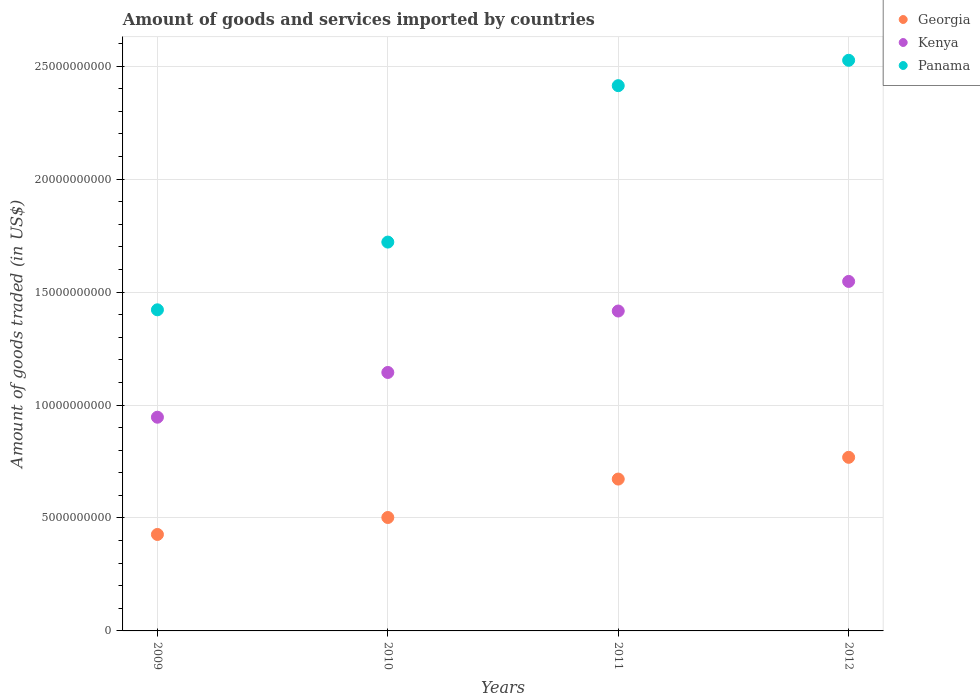How many different coloured dotlines are there?
Your response must be concise. 3. What is the total amount of goods and services imported in Georgia in 2010?
Your answer should be very brief. 5.02e+09. Across all years, what is the maximum total amount of goods and services imported in Kenya?
Offer a terse response. 1.55e+1. Across all years, what is the minimum total amount of goods and services imported in Georgia?
Offer a very short reply. 4.27e+09. In which year was the total amount of goods and services imported in Kenya minimum?
Give a very brief answer. 2009. What is the total total amount of goods and services imported in Kenya in the graph?
Your response must be concise. 5.05e+1. What is the difference between the total amount of goods and services imported in Kenya in 2011 and that in 2012?
Your response must be concise. -1.31e+09. What is the difference between the total amount of goods and services imported in Panama in 2011 and the total amount of goods and services imported in Kenya in 2009?
Your answer should be compact. 1.47e+1. What is the average total amount of goods and services imported in Georgia per year?
Ensure brevity in your answer.  5.92e+09. In the year 2012, what is the difference between the total amount of goods and services imported in Kenya and total amount of goods and services imported in Panama?
Your response must be concise. -9.79e+09. What is the ratio of the total amount of goods and services imported in Georgia in 2010 to that in 2012?
Ensure brevity in your answer.  0.65. Is the total amount of goods and services imported in Kenya in 2010 less than that in 2011?
Provide a short and direct response. Yes. What is the difference between the highest and the second highest total amount of goods and services imported in Kenya?
Give a very brief answer. 1.31e+09. What is the difference between the highest and the lowest total amount of goods and services imported in Georgia?
Your response must be concise. 3.41e+09. Is the sum of the total amount of goods and services imported in Panama in 2009 and 2012 greater than the maximum total amount of goods and services imported in Georgia across all years?
Your answer should be compact. Yes. Does the total amount of goods and services imported in Kenya monotonically increase over the years?
Provide a short and direct response. Yes. Is the total amount of goods and services imported in Panama strictly greater than the total amount of goods and services imported in Georgia over the years?
Provide a succinct answer. Yes. Is the total amount of goods and services imported in Panama strictly less than the total amount of goods and services imported in Kenya over the years?
Ensure brevity in your answer.  No. How many dotlines are there?
Offer a terse response. 3. Are the values on the major ticks of Y-axis written in scientific E-notation?
Make the answer very short. No. What is the title of the graph?
Your answer should be compact. Amount of goods and services imported by countries. What is the label or title of the Y-axis?
Your answer should be compact. Amount of goods traded (in US$). What is the Amount of goods traded (in US$) in Georgia in 2009?
Keep it short and to the point. 4.27e+09. What is the Amount of goods traded (in US$) in Kenya in 2009?
Give a very brief answer. 9.46e+09. What is the Amount of goods traded (in US$) in Panama in 2009?
Your answer should be compact. 1.42e+1. What is the Amount of goods traded (in US$) in Georgia in 2010?
Your answer should be compact. 5.02e+09. What is the Amount of goods traded (in US$) of Kenya in 2010?
Offer a terse response. 1.14e+1. What is the Amount of goods traded (in US$) in Panama in 2010?
Keep it short and to the point. 1.72e+1. What is the Amount of goods traded (in US$) of Georgia in 2011?
Ensure brevity in your answer.  6.72e+09. What is the Amount of goods traded (in US$) in Kenya in 2011?
Keep it short and to the point. 1.42e+1. What is the Amount of goods traded (in US$) of Panama in 2011?
Your answer should be very brief. 2.41e+1. What is the Amount of goods traded (in US$) of Georgia in 2012?
Your answer should be compact. 7.69e+09. What is the Amount of goods traded (in US$) of Kenya in 2012?
Keep it short and to the point. 1.55e+1. What is the Amount of goods traded (in US$) of Panama in 2012?
Your answer should be very brief. 2.53e+1. Across all years, what is the maximum Amount of goods traded (in US$) of Georgia?
Keep it short and to the point. 7.69e+09. Across all years, what is the maximum Amount of goods traded (in US$) in Kenya?
Your response must be concise. 1.55e+1. Across all years, what is the maximum Amount of goods traded (in US$) in Panama?
Your response must be concise. 2.53e+1. Across all years, what is the minimum Amount of goods traded (in US$) in Georgia?
Provide a succinct answer. 4.27e+09. Across all years, what is the minimum Amount of goods traded (in US$) of Kenya?
Your answer should be compact. 9.46e+09. Across all years, what is the minimum Amount of goods traded (in US$) in Panama?
Your answer should be compact. 1.42e+1. What is the total Amount of goods traded (in US$) in Georgia in the graph?
Ensure brevity in your answer.  2.37e+1. What is the total Amount of goods traded (in US$) in Kenya in the graph?
Ensure brevity in your answer.  5.05e+1. What is the total Amount of goods traded (in US$) of Panama in the graph?
Provide a succinct answer. 8.08e+1. What is the difference between the Amount of goods traded (in US$) in Georgia in 2009 and that in 2010?
Offer a very short reply. -7.51e+08. What is the difference between the Amount of goods traded (in US$) in Kenya in 2009 and that in 2010?
Your answer should be compact. -1.98e+09. What is the difference between the Amount of goods traded (in US$) in Panama in 2009 and that in 2010?
Offer a very short reply. -3.00e+09. What is the difference between the Amount of goods traded (in US$) of Georgia in 2009 and that in 2011?
Ensure brevity in your answer.  -2.45e+09. What is the difference between the Amount of goods traded (in US$) in Kenya in 2009 and that in 2011?
Offer a terse response. -4.70e+09. What is the difference between the Amount of goods traded (in US$) of Panama in 2009 and that in 2011?
Ensure brevity in your answer.  -9.92e+09. What is the difference between the Amount of goods traded (in US$) of Georgia in 2009 and that in 2012?
Keep it short and to the point. -3.41e+09. What is the difference between the Amount of goods traded (in US$) of Kenya in 2009 and that in 2012?
Offer a very short reply. -6.01e+09. What is the difference between the Amount of goods traded (in US$) in Panama in 2009 and that in 2012?
Keep it short and to the point. -1.10e+1. What is the difference between the Amount of goods traded (in US$) of Georgia in 2010 and that in 2011?
Your answer should be very brief. -1.70e+09. What is the difference between the Amount of goods traded (in US$) of Kenya in 2010 and that in 2011?
Offer a very short reply. -2.72e+09. What is the difference between the Amount of goods traded (in US$) of Panama in 2010 and that in 2011?
Your answer should be very brief. -6.92e+09. What is the difference between the Amount of goods traded (in US$) of Georgia in 2010 and that in 2012?
Keep it short and to the point. -2.66e+09. What is the difference between the Amount of goods traded (in US$) in Kenya in 2010 and that in 2012?
Provide a short and direct response. -4.03e+09. What is the difference between the Amount of goods traded (in US$) of Panama in 2010 and that in 2012?
Your answer should be compact. -8.05e+09. What is the difference between the Amount of goods traded (in US$) in Georgia in 2011 and that in 2012?
Your answer should be very brief. -9.63e+08. What is the difference between the Amount of goods traded (in US$) of Kenya in 2011 and that in 2012?
Your answer should be very brief. -1.31e+09. What is the difference between the Amount of goods traded (in US$) in Panama in 2011 and that in 2012?
Ensure brevity in your answer.  -1.12e+09. What is the difference between the Amount of goods traded (in US$) of Georgia in 2009 and the Amount of goods traded (in US$) of Kenya in 2010?
Your answer should be compact. -7.17e+09. What is the difference between the Amount of goods traded (in US$) in Georgia in 2009 and the Amount of goods traded (in US$) in Panama in 2010?
Offer a terse response. -1.29e+1. What is the difference between the Amount of goods traded (in US$) of Kenya in 2009 and the Amount of goods traded (in US$) of Panama in 2010?
Make the answer very short. -7.75e+09. What is the difference between the Amount of goods traded (in US$) of Georgia in 2009 and the Amount of goods traded (in US$) of Kenya in 2011?
Make the answer very short. -9.89e+09. What is the difference between the Amount of goods traded (in US$) of Georgia in 2009 and the Amount of goods traded (in US$) of Panama in 2011?
Ensure brevity in your answer.  -1.99e+1. What is the difference between the Amount of goods traded (in US$) in Kenya in 2009 and the Amount of goods traded (in US$) in Panama in 2011?
Provide a succinct answer. -1.47e+1. What is the difference between the Amount of goods traded (in US$) of Georgia in 2009 and the Amount of goods traded (in US$) of Kenya in 2012?
Ensure brevity in your answer.  -1.12e+1. What is the difference between the Amount of goods traded (in US$) in Georgia in 2009 and the Amount of goods traded (in US$) in Panama in 2012?
Offer a terse response. -2.10e+1. What is the difference between the Amount of goods traded (in US$) of Kenya in 2009 and the Amount of goods traded (in US$) of Panama in 2012?
Offer a very short reply. -1.58e+1. What is the difference between the Amount of goods traded (in US$) in Georgia in 2010 and the Amount of goods traded (in US$) in Kenya in 2011?
Your response must be concise. -9.14e+09. What is the difference between the Amount of goods traded (in US$) in Georgia in 2010 and the Amount of goods traded (in US$) in Panama in 2011?
Make the answer very short. -1.91e+1. What is the difference between the Amount of goods traded (in US$) in Kenya in 2010 and the Amount of goods traded (in US$) in Panama in 2011?
Your answer should be compact. -1.27e+1. What is the difference between the Amount of goods traded (in US$) of Georgia in 2010 and the Amount of goods traded (in US$) of Kenya in 2012?
Make the answer very short. -1.05e+1. What is the difference between the Amount of goods traded (in US$) of Georgia in 2010 and the Amount of goods traded (in US$) of Panama in 2012?
Ensure brevity in your answer.  -2.02e+1. What is the difference between the Amount of goods traded (in US$) of Kenya in 2010 and the Amount of goods traded (in US$) of Panama in 2012?
Offer a very short reply. -1.38e+1. What is the difference between the Amount of goods traded (in US$) of Georgia in 2011 and the Amount of goods traded (in US$) of Kenya in 2012?
Give a very brief answer. -8.75e+09. What is the difference between the Amount of goods traded (in US$) of Georgia in 2011 and the Amount of goods traded (in US$) of Panama in 2012?
Offer a terse response. -1.85e+1. What is the difference between the Amount of goods traded (in US$) in Kenya in 2011 and the Amount of goods traded (in US$) in Panama in 2012?
Your answer should be very brief. -1.11e+1. What is the average Amount of goods traded (in US$) of Georgia per year?
Your answer should be very brief. 5.92e+09. What is the average Amount of goods traded (in US$) of Kenya per year?
Ensure brevity in your answer.  1.26e+1. What is the average Amount of goods traded (in US$) in Panama per year?
Your answer should be very brief. 2.02e+1. In the year 2009, what is the difference between the Amount of goods traded (in US$) in Georgia and Amount of goods traded (in US$) in Kenya?
Ensure brevity in your answer.  -5.19e+09. In the year 2009, what is the difference between the Amount of goods traded (in US$) of Georgia and Amount of goods traded (in US$) of Panama?
Give a very brief answer. -9.95e+09. In the year 2009, what is the difference between the Amount of goods traded (in US$) in Kenya and Amount of goods traded (in US$) in Panama?
Your response must be concise. -4.75e+09. In the year 2010, what is the difference between the Amount of goods traded (in US$) of Georgia and Amount of goods traded (in US$) of Kenya?
Your answer should be compact. -6.42e+09. In the year 2010, what is the difference between the Amount of goods traded (in US$) of Georgia and Amount of goods traded (in US$) of Panama?
Your answer should be very brief. -1.22e+1. In the year 2010, what is the difference between the Amount of goods traded (in US$) in Kenya and Amount of goods traded (in US$) in Panama?
Your response must be concise. -5.77e+09. In the year 2011, what is the difference between the Amount of goods traded (in US$) of Georgia and Amount of goods traded (in US$) of Kenya?
Ensure brevity in your answer.  -7.44e+09. In the year 2011, what is the difference between the Amount of goods traded (in US$) of Georgia and Amount of goods traded (in US$) of Panama?
Provide a succinct answer. -1.74e+1. In the year 2011, what is the difference between the Amount of goods traded (in US$) in Kenya and Amount of goods traded (in US$) in Panama?
Offer a terse response. -9.98e+09. In the year 2012, what is the difference between the Amount of goods traded (in US$) of Georgia and Amount of goods traded (in US$) of Kenya?
Offer a very short reply. -7.79e+09. In the year 2012, what is the difference between the Amount of goods traded (in US$) in Georgia and Amount of goods traded (in US$) in Panama?
Offer a terse response. -1.76e+1. In the year 2012, what is the difference between the Amount of goods traded (in US$) in Kenya and Amount of goods traded (in US$) in Panama?
Your answer should be compact. -9.79e+09. What is the ratio of the Amount of goods traded (in US$) of Georgia in 2009 to that in 2010?
Your answer should be very brief. 0.85. What is the ratio of the Amount of goods traded (in US$) of Kenya in 2009 to that in 2010?
Offer a terse response. 0.83. What is the ratio of the Amount of goods traded (in US$) in Panama in 2009 to that in 2010?
Provide a short and direct response. 0.83. What is the ratio of the Amount of goods traded (in US$) in Georgia in 2009 to that in 2011?
Your answer should be compact. 0.64. What is the ratio of the Amount of goods traded (in US$) of Kenya in 2009 to that in 2011?
Provide a short and direct response. 0.67. What is the ratio of the Amount of goods traded (in US$) of Panama in 2009 to that in 2011?
Your response must be concise. 0.59. What is the ratio of the Amount of goods traded (in US$) in Georgia in 2009 to that in 2012?
Your answer should be very brief. 0.56. What is the ratio of the Amount of goods traded (in US$) in Kenya in 2009 to that in 2012?
Offer a terse response. 0.61. What is the ratio of the Amount of goods traded (in US$) in Panama in 2009 to that in 2012?
Ensure brevity in your answer.  0.56. What is the ratio of the Amount of goods traded (in US$) of Georgia in 2010 to that in 2011?
Make the answer very short. 0.75. What is the ratio of the Amount of goods traded (in US$) of Kenya in 2010 to that in 2011?
Provide a succinct answer. 0.81. What is the ratio of the Amount of goods traded (in US$) in Panama in 2010 to that in 2011?
Ensure brevity in your answer.  0.71. What is the ratio of the Amount of goods traded (in US$) in Georgia in 2010 to that in 2012?
Offer a terse response. 0.65. What is the ratio of the Amount of goods traded (in US$) in Kenya in 2010 to that in 2012?
Your response must be concise. 0.74. What is the ratio of the Amount of goods traded (in US$) in Panama in 2010 to that in 2012?
Provide a short and direct response. 0.68. What is the ratio of the Amount of goods traded (in US$) of Georgia in 2011 to that in 2012?
Provide a succinct answer. 0.87. What is the ratio of the Amount of goods traded (in US$) in Kenya in 2011 to that in 2012?
Provide a succinct answer. 0.92. What is the ratio of the Amount of goods traded (in US$) of Panama in 2011 to that in 2012?
Make the answer very short. 0.96. What is the difference between the highest and the second highest Amount of goods traded (in US$) of Georgia?
Your answer should be very brief. 9.63e+08. What is the difference between the highest and the second highest Amount of goods traded (in US$) in Kenya?
Keep it short and to the point. 1.31e+09. What is the difference between the highest and the second highest Amount of goods traded (in US$) in Panama?
Your answer should be very brief. 1.12e+09. What is the difference between the highest and the lowest Amount of goods traded (in US$) in Georgia?
Your answer should be compact. 3.41e+09. What is the difference between the highest and the lowest Amount of goods traded (in US$) in Kenya?
Your response must be concise. 6.01e+09. What is the difference between the highest and the lowest Amount of goods traded (in US$) of Panama?
Offer a terse response. 1.10e+1. 